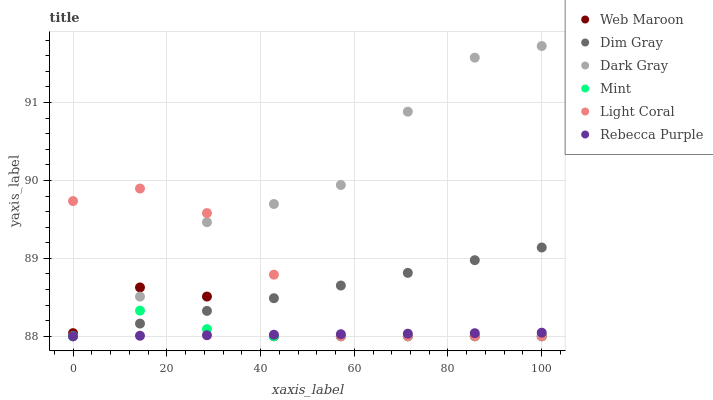Does Rebecca Purple have the minimum area under the curve?
Answer yes or no. Yes. Does Dark Gray have the maximum area under the curve?
Answer yes or no. Yes. Does Dim Gray have the minimum area under the curve?
Answer yes or no. No. Does Dim Gray have the maximum area under the curve?
Answer yes or no. No. Is Dim Gray the smoothest?
Answer yes or no. Yes. Is Dark Gray the roughest?
Answer yes or no. Yes. Is Web Maroon the smoothest?
Answer yes or no. No. Is Web Maroon the roughest?
Answer yes or no. No. Does Light Coral have the lowest value?
Answer yes or no. Yes. Does Dark Gray have the highest value?
Answer yes or no. Yes. Does Dim Gray have the highest value?
Answer yes or no. No. Does Rebecca Purple intersect Web Maroon?
Answer yes or no. Yes. Is Rebecca Purple less than Web Maroon?
Answer yes or no. No. Is Rebecca Purple greater than Web Maroon?
Answer yes or no. No. 